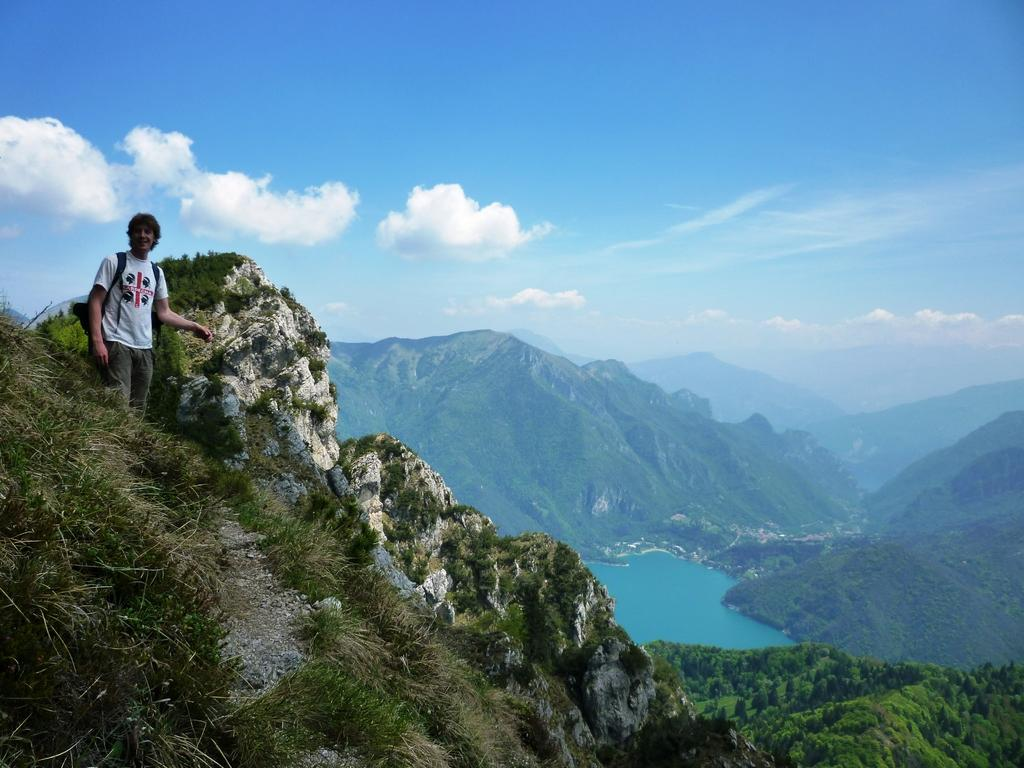What is the person in the image doing? The person is standing on a hill on the left side of the image. What can be seen in the distance behind the person? There are hills, trees, and the sky visible in the background of the image. What is the condition of the sky in the image? The sky is visible in the background of the image, and clouds are present. What type of vegetation is at the bottom of the image? There is grass at the bottom of the image. What type of crook can be seen in the image? There is no crook present in the image. How does the person in the image use the bit to control the animal? There is no animal or bit present in the image; the person is simply standing on a hill. 